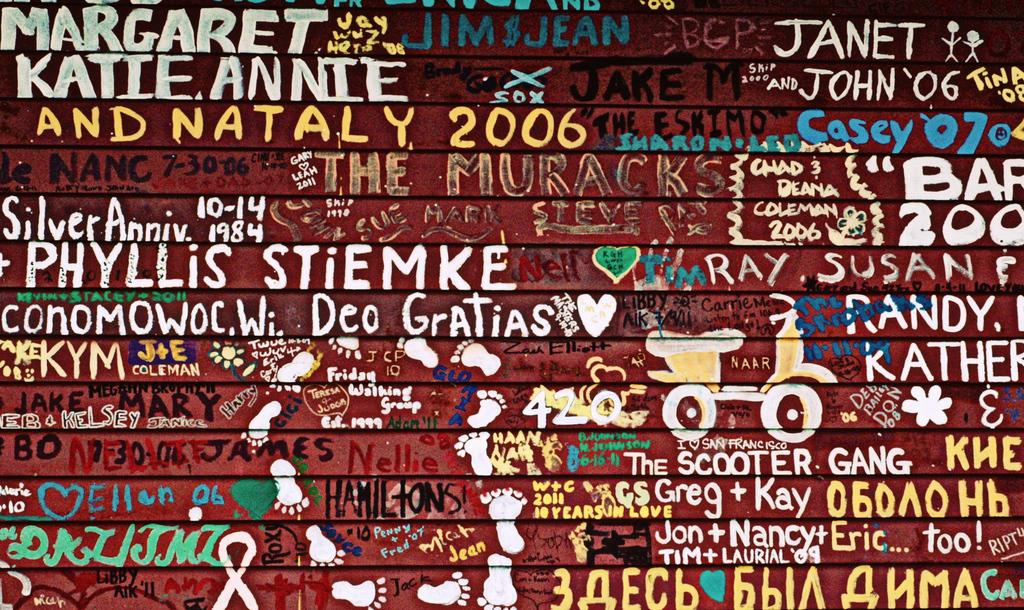Provide a one-sentence caption for the provided image. a collage poster with names like ray, susan. 